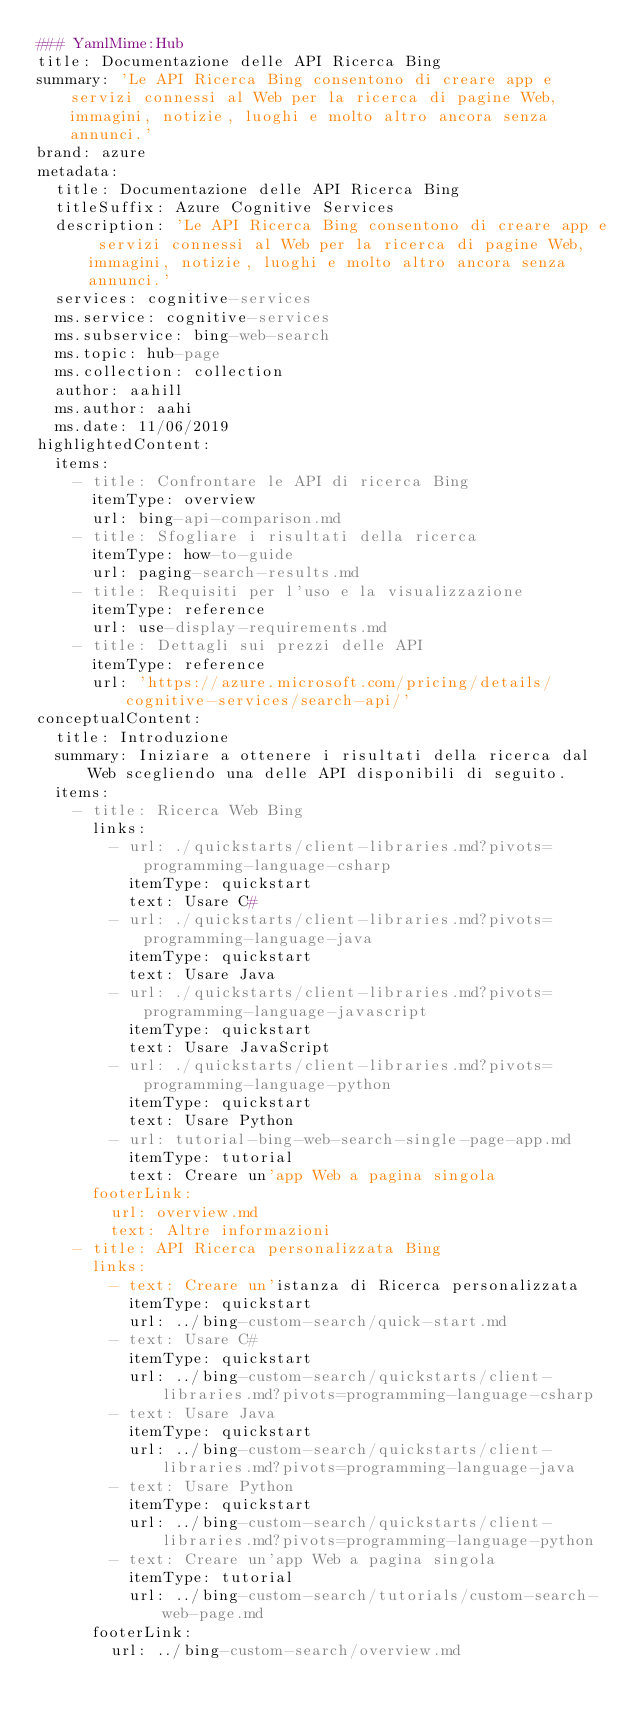Convert code to text. <code><loc_0><loc_0><loc_500><loc_500><_YAML_>### YamlMime:Hub
title: Documentazione delle API Ricerca Bing
summary: 'Le API Ricerca Bing consentono di creare app e servizi connessi al Web per la ricerca di pagine Web, immagini, notizie, luoghi e molto altro ancora senza annunci.'
brand: azure
metadata:
  title: Documentazione delle API Ricerca Bing
  titleSuffix: Azure Cognitive Services
  description: 'Le API Ricerca Bing consentono di creare app e servizi connessi al Web per la ricerca di pagine Web, immagini, notizie, luoghi e molto altro ancora senza annunci.'
  services: cognitive-services
  ms.service: cognitive-services
  ms.subservice: bing-web-search
  ms.topic: hub-page
  ms.collection: collection
  author: aahill
  ms.author: aahi
  ms.date: 11/06/2019
highlightedContent:
  items:
    - title: Confrontare le API di ricerca Bing
      itemType: overview
      url: bing-api-comparison.md
    - title: Sfogliare i risultati della ricerca
      itemType: how-to-guide
      url: paging-search-results.md
    - title: Requisiti per l'uso e la visualizzazione
      itemType: reference
      url: use-display-requirements.md
    - title: Dettagli sui prezzi delle API
      itemType: reference
      url: 'https://azure.microsoft.com/pricing/details/cognitive-services/search-api/'
conceptualContent:
  title: Introduzione
  summary: Iniziare a ottenere i risultati della ricerca dal Web scegliendo una delle API disponibili di seguito.
  items:
    - title: Ricerca Web Bing
      links:
        - url: ./quickstarts/client-libraries.md?pivots=programming-language-csharp
          itemType: quickstart
          text: Usare C#
        - url: ./quickstarts/client-libraries.md?pivots=programming-language-java
          itemType: quickstart
          text: Usare Java
        - url: ./quickstarts/client-libraries.md?pivots=programming-language-javascript
          itemType: quickstart
          text: Usare JavaScript
        - url: ./quickstarts/client-libraries.md?pivots=programming-language-python
          itemType: quickstart
          text: Usare Python
        - url: tutorial-bing-web-search-single-page-app.md
          itemType: tutorial
          text: Creare un'app Web a pagina singola
      footerLink:
        url: overview.md
        text: Altre informazioni
    - title: API Ricerca personalizzata Bing
      links:
        - text: Creare un'istanza di Ricerca personalizzata
          itemType: quickstart
          url: ../bing-custom-search/quick-start.md
        - text: Usare C#
          itemType: quickstart
          url: ../bing-custom-search/quickstarts/client-libraries.md?pivots=programming-language-csharp
        - text: Usare Java
          itemType: quickstart
          url: ../bing-custom-search/quickstarts/client-libraries.md?pivots=programming-language-java
        - text: Usare Python
          itemType: quickstart
          url: ../bing-custom-search/quickstarts/client-libraries.md?pivots=programming-language-python
        - text: Creare un'app Web a pagina singola
          itemType: tutorial
          url: ../bing-custom-search/tutorials/custom-search-web-page.md
      footerLink:
        url: ../bing-custom-search/overview.md</code> 